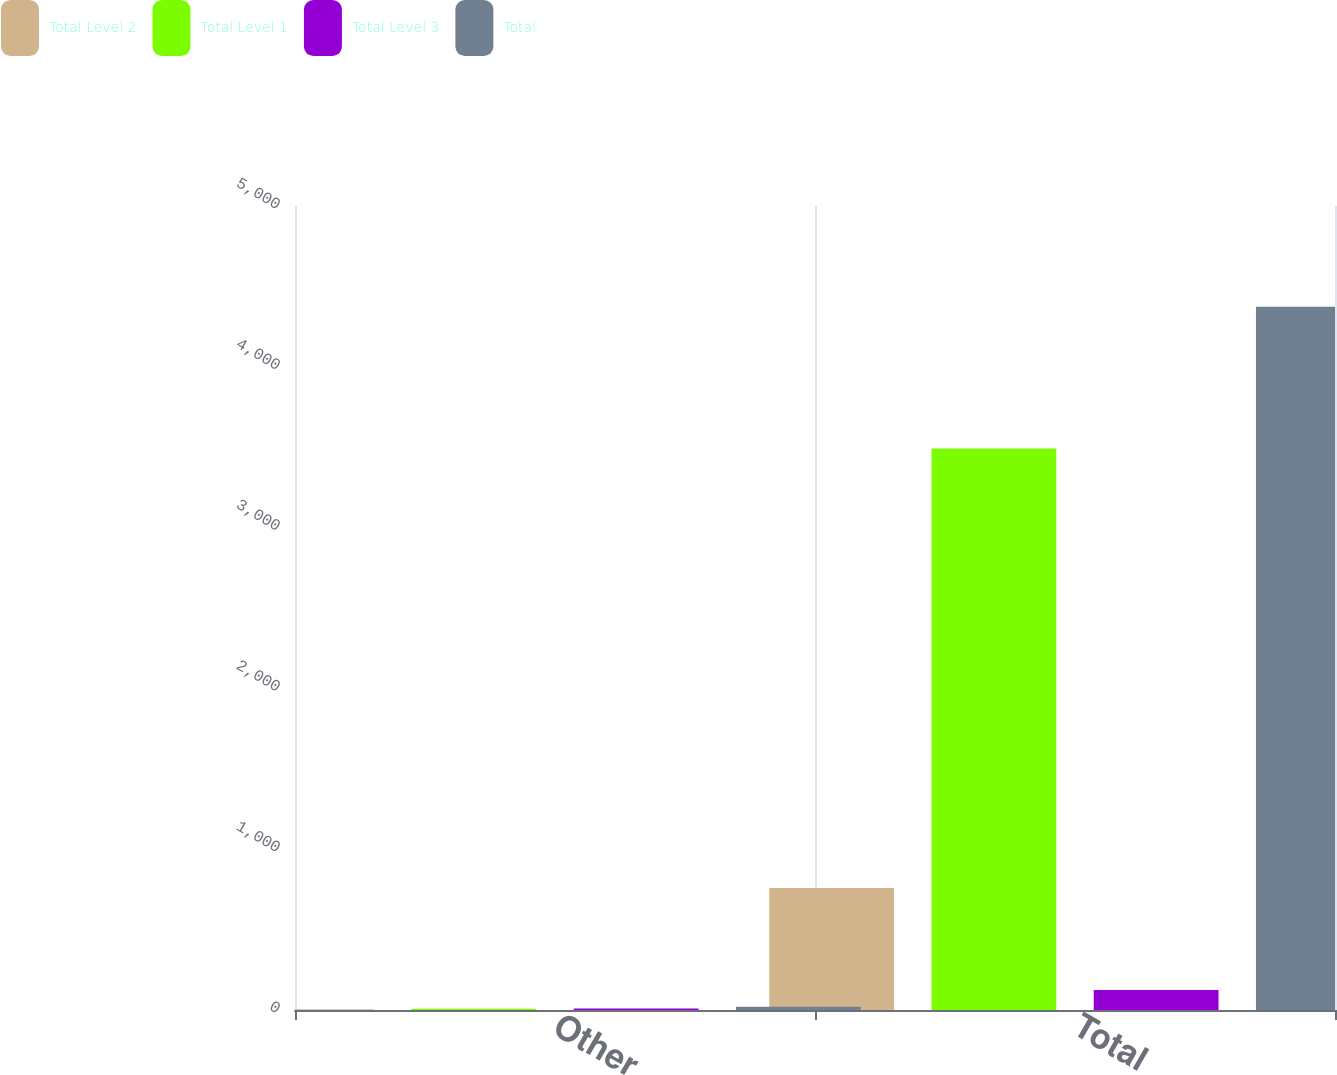Convert chart. <chart><loc_0><loc_0><loc_500><loc_500><stacked_bar_chart><ecel><fcel>Other<fcel>Total<nl><fcel>Total Level 2<fcel>4<fcel>758<nl><fcel>Total Level 1<fcel>7<fcel>3492<nl><fcel>Total Level 3<fcel>9<fcel>124<nl><fcel>Total<fcel>20<fcel>4374<nl></chart> 